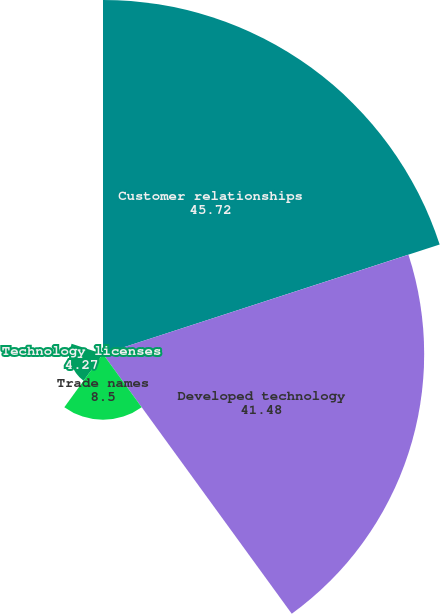Convert chart. <chart><loc_0><loc_0><loc_500><loc_500><pie_chart><fcel>Customer relationships<fcel>Developed technology<fcel>Trade names<fcel>Technology licenses<fcel>Non-compete agreement<nl><fcel>45.72%<fcel>41.48%<fcel>8.5%<fcel>4.27%<fcel>0.03%<nl></chart> 